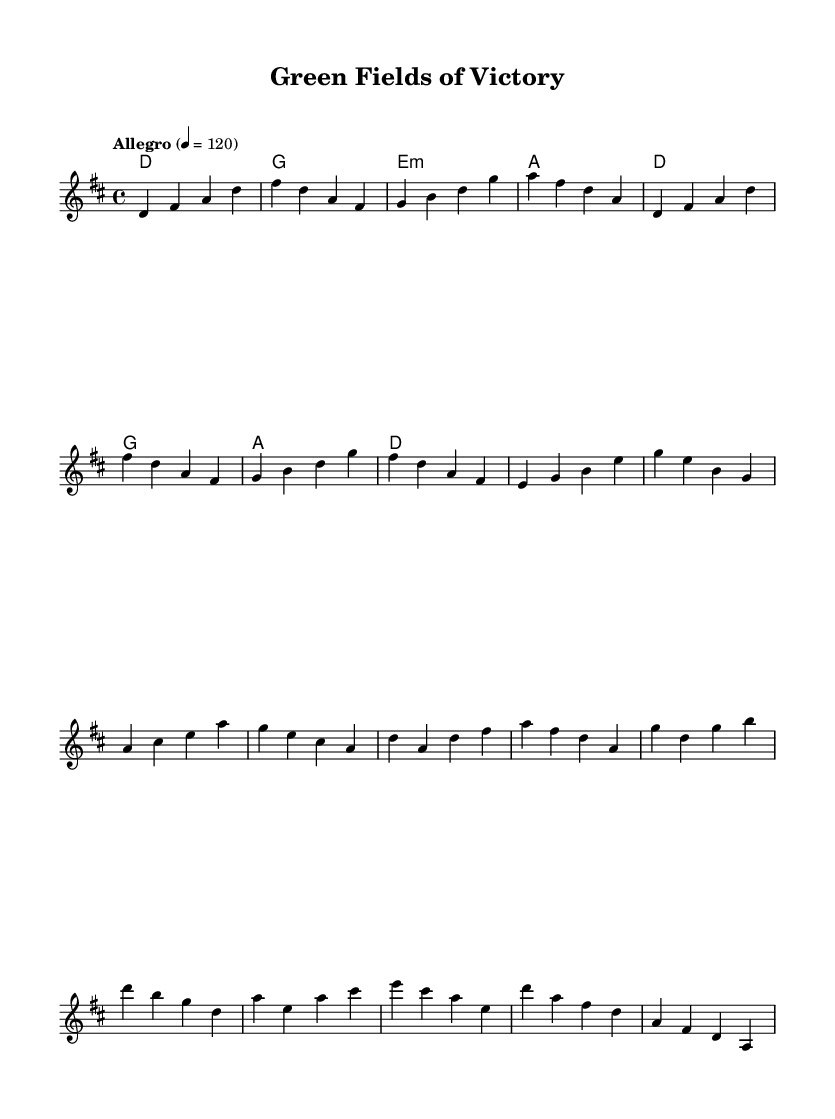What is the key signature of this music? The key signature indicates the tonal center of the piece, which is D major. This means there are two sharps: F# and C#.
Answer: D major What is the time signature of this music? The time signature is indicated at the beginning of the piece, showing there are four beats in each measure. It is specified as 4/4.
Answer: 4/4 What is the tempo marking for this piece? The tempo marking indicates how fast the music is to be played. In this sheet music, it is marked as "Allegro" with a beat of 120.
Answer: Allegro 4 = 120 How many measures are in the verse? Counting the measures indicated in the melody section explicitly shows there are eight measures in the verse.
Answer: 8 What is the first chord of the chorus? The first chord is the initial harmony played during the chorus, as indicated by the chord symbols above the staff. It is a D major chord.
Answer: D In which section do the lyrics mention "Irish pride"? The phrase "Irish pride" occurs in the chorus section of the lyrics, which celebrates the achievements in Irish sports.
Answer: Chorus What is the repeated lyrical phrase in the chorus? Analyzing the chorus lyrics, the repeated phrase "Green fields of sporting dreams" is highlighted and emphasizes the theme of the song.
Answer: Green fields of sporting dreams 